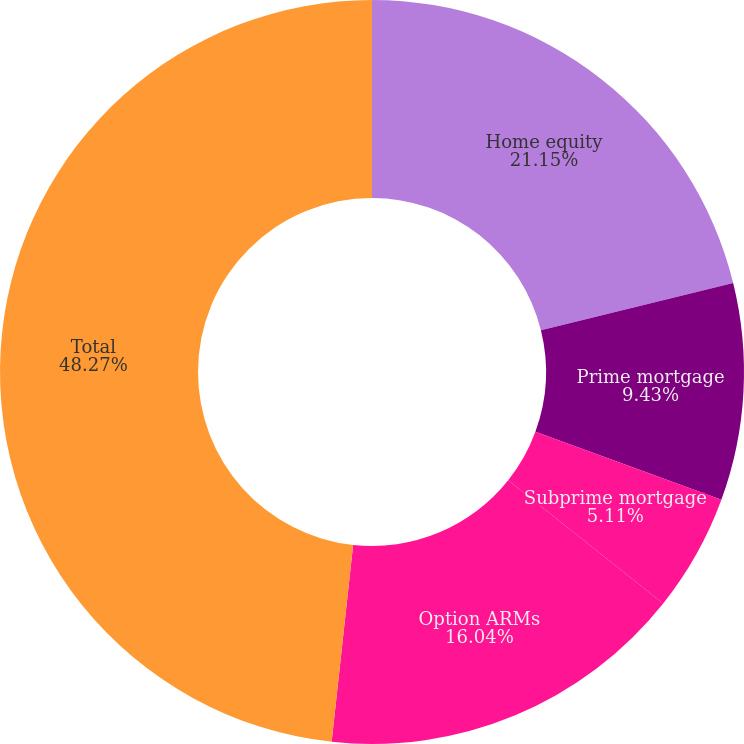Convert chart to OTSL. <chart><loc_0><loc_0><loc_500><loc_500><pie_chart><fcel>Home equity<fcel>Prime mortgage<fcel>Subprime mortgage<fcel>Option ARMs<fcel>Total<nl><fcel>21.15%<fcel>9.43%<fcel>5.11%<fcel>16.04%<fcel>48.27%<nl></chart> 